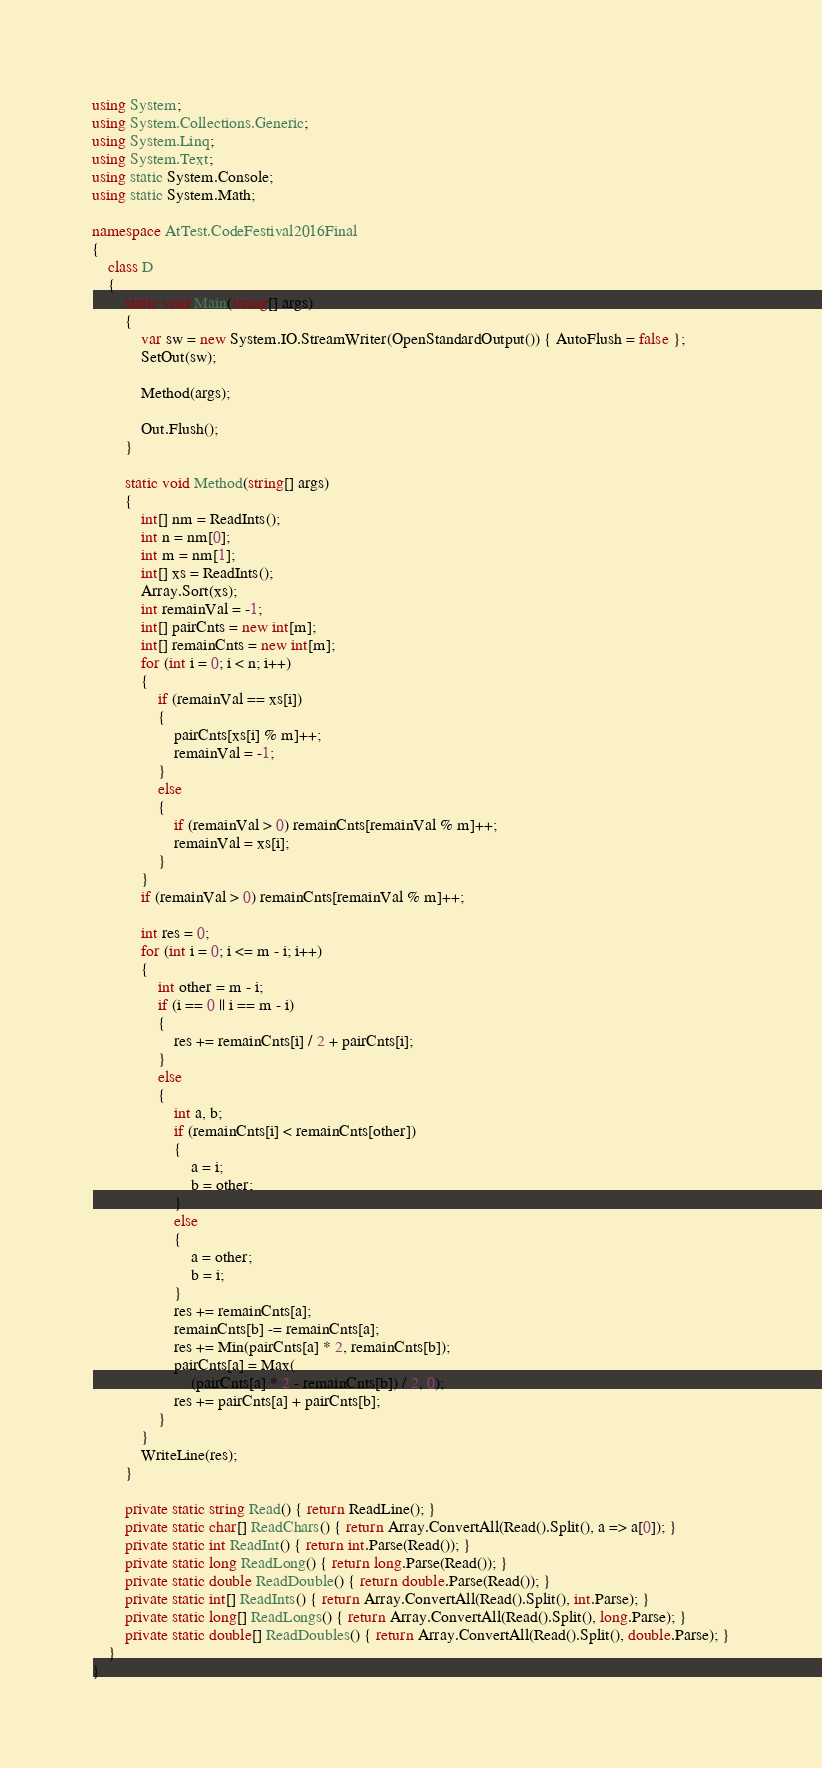Convert code to text. <code><loc_0><loc_0><loc_500><loc_500><_C#_>using System;
using System.Collections.Generic;
using System.Linq;
using System.Text;
using static System.Console;
using static System.Math;

namespace AtTest.CodeFestival2016Final
{
    class D
    {
        static void Main(string[] args)
        {
            var sw = new System.IO.StreamWriter(OpenStandardOutput()) { AutoFlush = false };
            SetOut(sw);

            Method(args);

            Out.Flush();
        }

        static void Method(string[] args)
        {
            int[] nm = ReadInts();
            int n = nm[0];
            int m = nm[1];
            int[] xs = ReadInts();
            Array.Sort(xs);
            int remainVal = -1;
            int[] pairCnts = new int[m];
            int[] remainCnts = new int[m];
            for (int i = 0; i < n; i++)
            {
                if (remainVal == xs[i])
                {
                    pairCnts[xs[i] % m]++;
                    remainVal = -1;
                }
                else
                {
                    if (remainVal > 0) remainCnts[remainVal % m]++;
                    remainVal = xs[i];
                }
            }
            if (remainVal > 0) remainCnts[remainVal % m]++;

            int res = 0;
            for (int i = 0; i <= m - i; i++)
            {
                int other = m - i;
                if (i == 0 || i == m - i)
                {
                    res += remainCnts[i] / 2 + pairCnts[i];
                }
                else
                {
                    int a, b;
                    if (remainCnts[i] < remainCnts[other])
                    {
                        a = i;
                        b = other;
                    }
                    else
                    {
                        a = other;
                        b = i;
                    }
                    res += remainCnts[a];
                    remainCnts[b] -= remainCnts[a];
                    res += Min(pairCnts[a] * 2, remainCnts[b]);
                    pairCnts[a] = Max(
                        (pairCnts[a] * 2 - remainCnts[b]) / 2, 0);
                    res += pairCnts[a] + pairCnts[b];
                }
            }
            WriteLine(res);
        }

        private static string Read() { return ReadLine(); }
        private static char[] ReadChars() { return Array.ConvertAll(Read().Split(), a => a[0]); }
        private static int ReadInt() { return int.Parse(Read()); }
        private static long ReadLong() { return long.Parse(Read()); }
        private static double ReadDouble() { return double.Parse(Read()); }
        private static int[] ReadInts() { return Array.ConvertAll(Read().Split(), int.Parse); }
        private static long[] ReadLongs() { return Array.ConvertAll(Read().Split(), long.Parse); }
        private static double[] ReadDoubles() { return Array.ConvertAll(Read().Split(), double.Parse); }
    }
}
</code> 